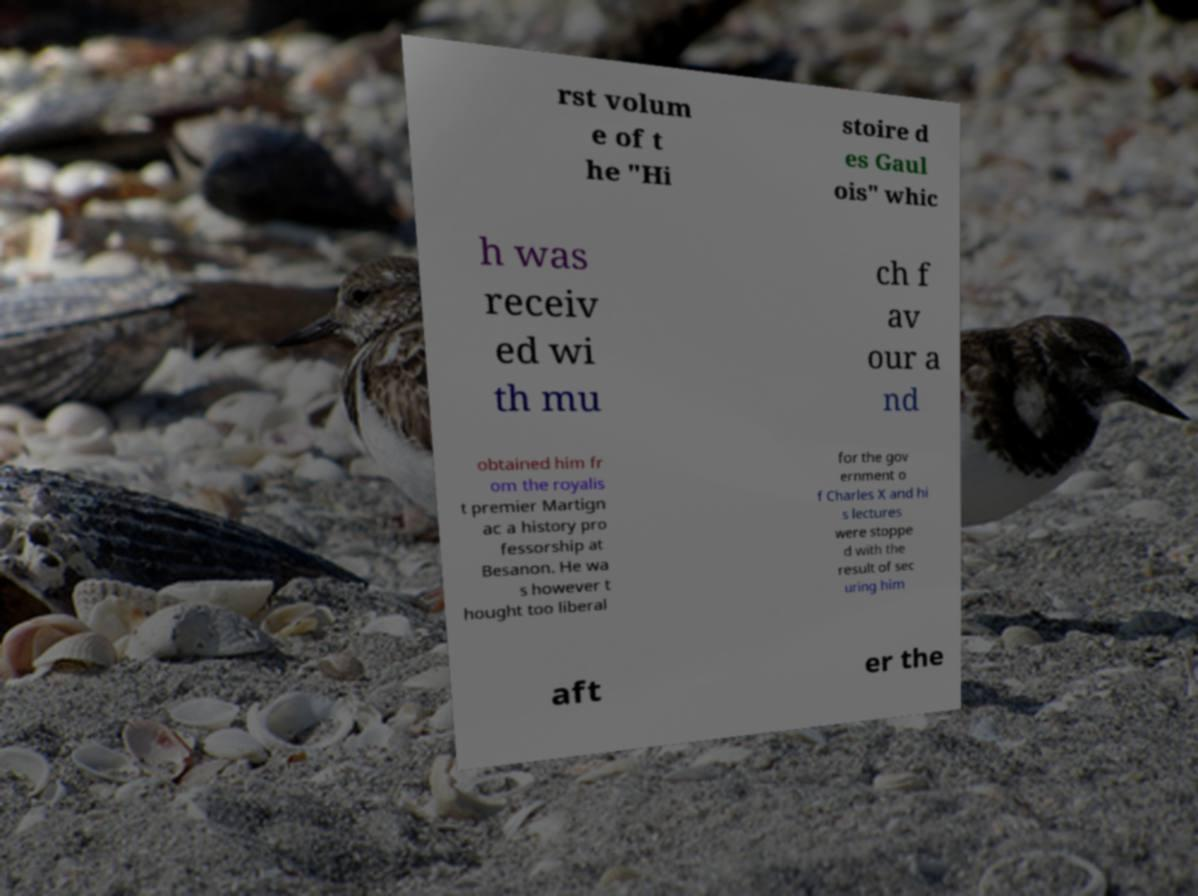There's text embedded in this image that I need extracted. Can you transcribe it verbatim? rst volum e of t he "Hi stoire d es Gaul ois" whic h was receiv ed wi th mu ch f av our a nd obtained him fr om the royalis t premier Martign ac a history pro fessorship at Besanon. He wa s however t hought too liberal for the gov ernment o f Charles X and hi s lectures were stoppe d with the result of sec uring him aft er the 